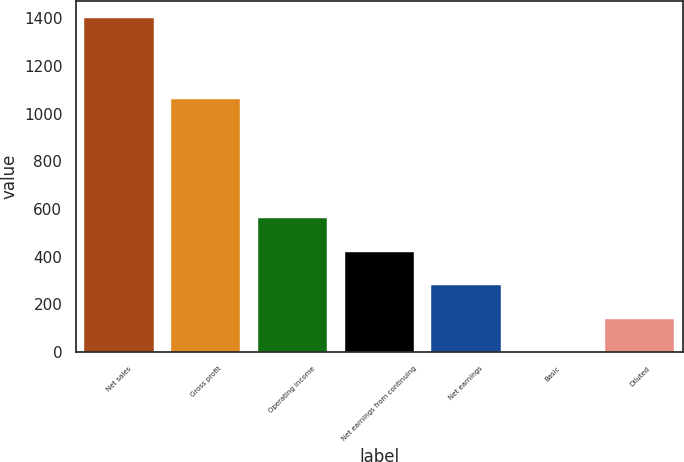Convert chart to OTSL. <chart><loc_0><loc_0><loc_500><loc_500><bar_chart><fcel>Net sales<fcel>Gross profit<fcel>Operating income<fcel>Net earnings from continuing<fcel>Net earnings<fcel>Basic<fcel>Diluted<nl><fcel>1403.1<fcel>1062.2<fcel>561.43<fcel>421.15<fcel>280.87<fcel>0.31<fcel>140.59<nl></chart> 